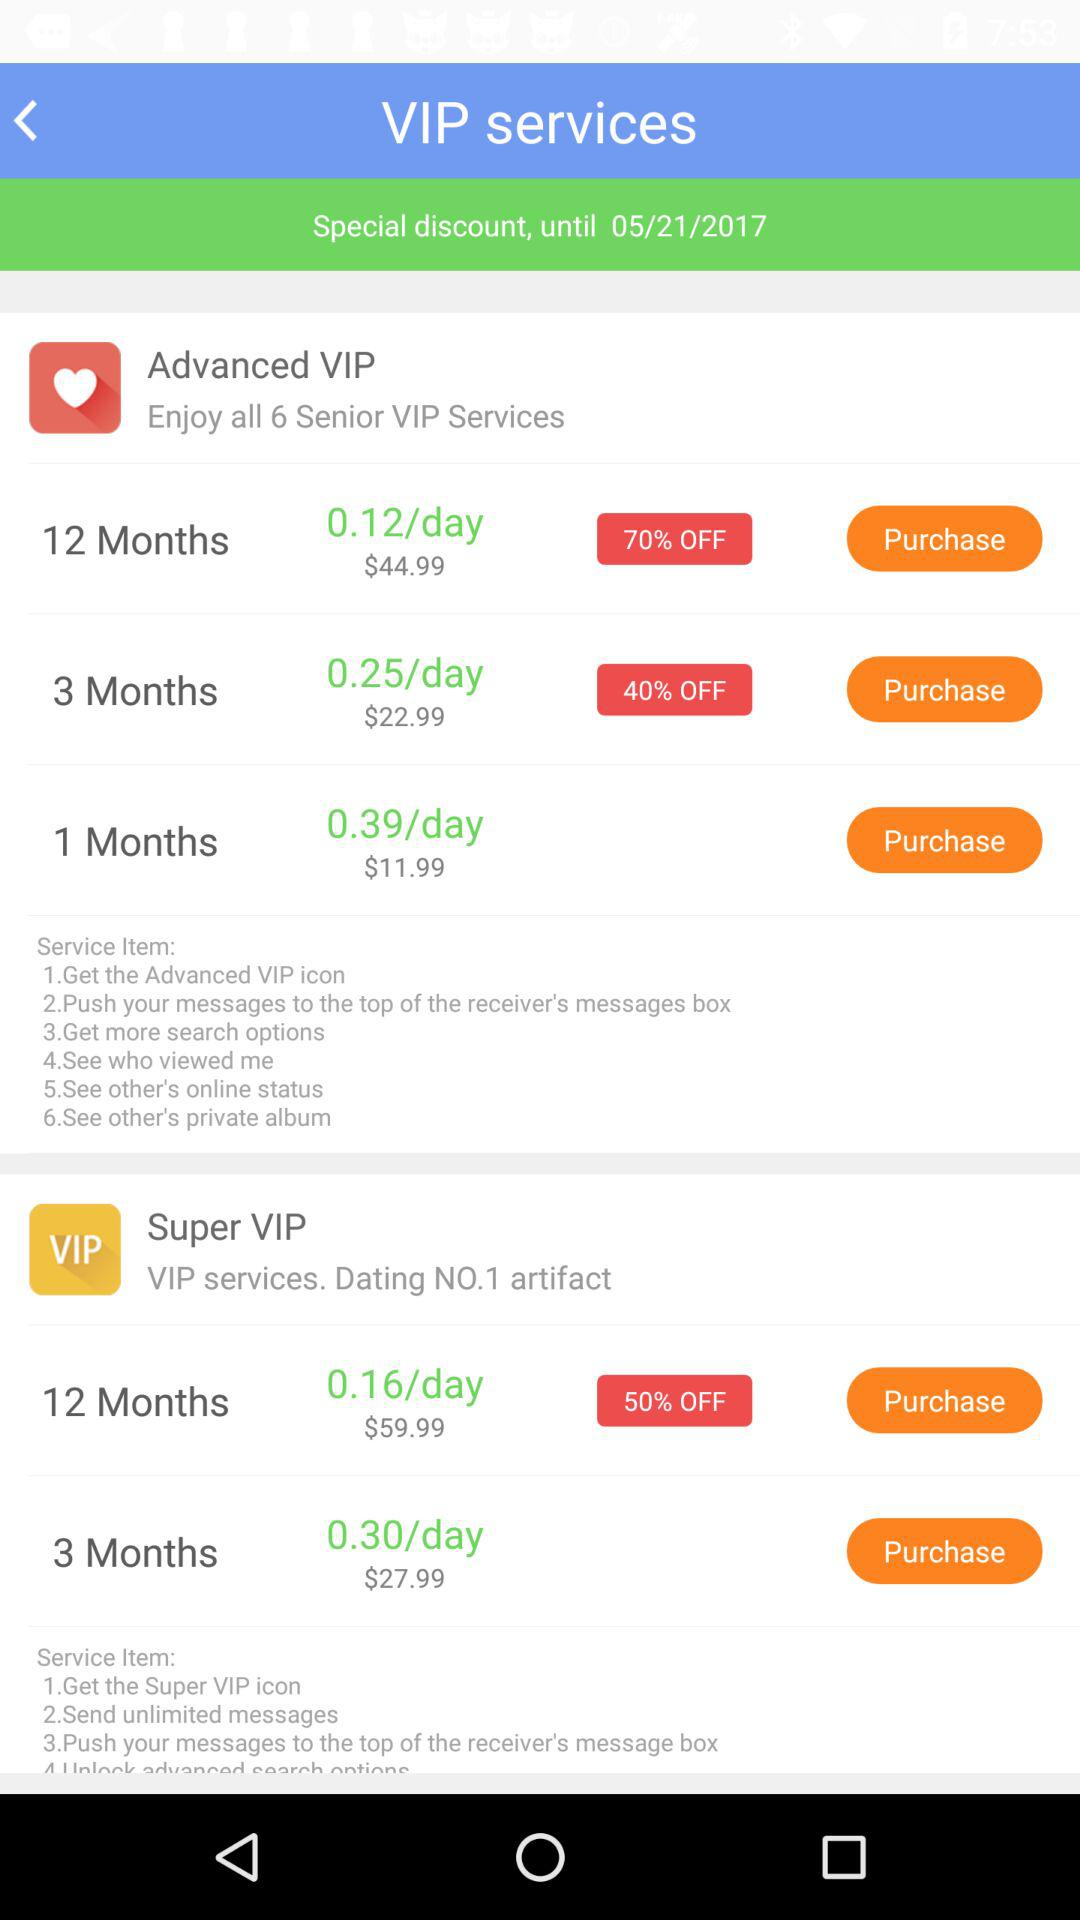What is the price of the Advance VIP three-month service? The price of the Advance VIP three-month service is $22.99. 